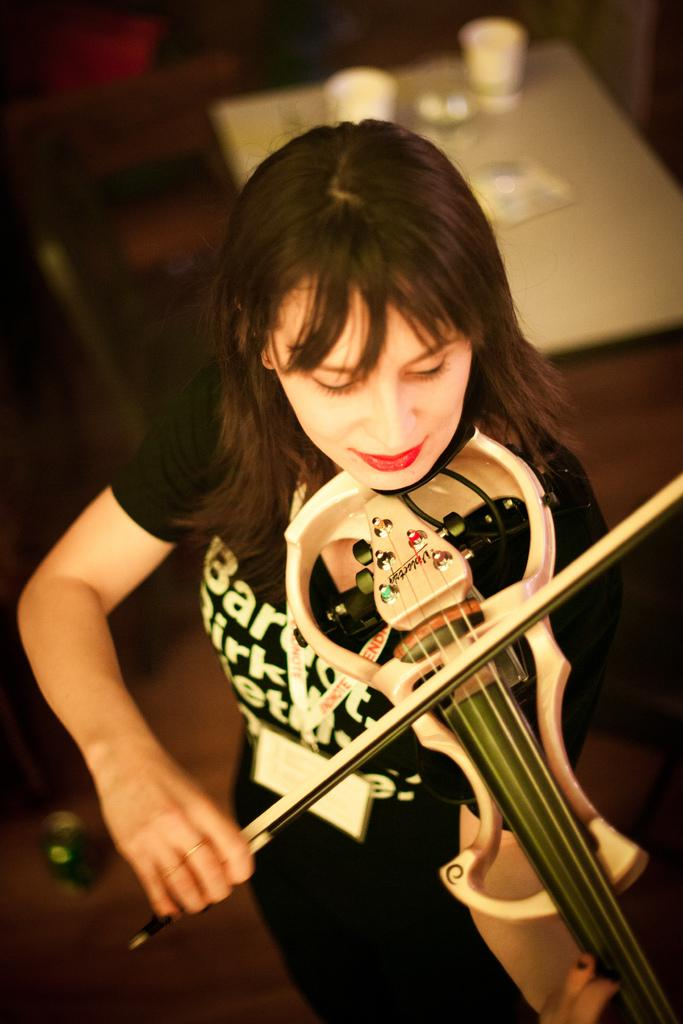Who is the main subject in the image? There is a girl in the image. Where is the girl positioned in the image? The girl is at the center of the image. What is the girl doing in the image? The girl is playing the violin. What object can be seen behind the girl? There is a table in the image, and it is behind the girl. On which side of the image is the table located? The table is on the right side of the image. What is the reaction of the kittens to the girl playing the violin in the image? There are no kittens present in the image, so their reaction cannot be determined. 